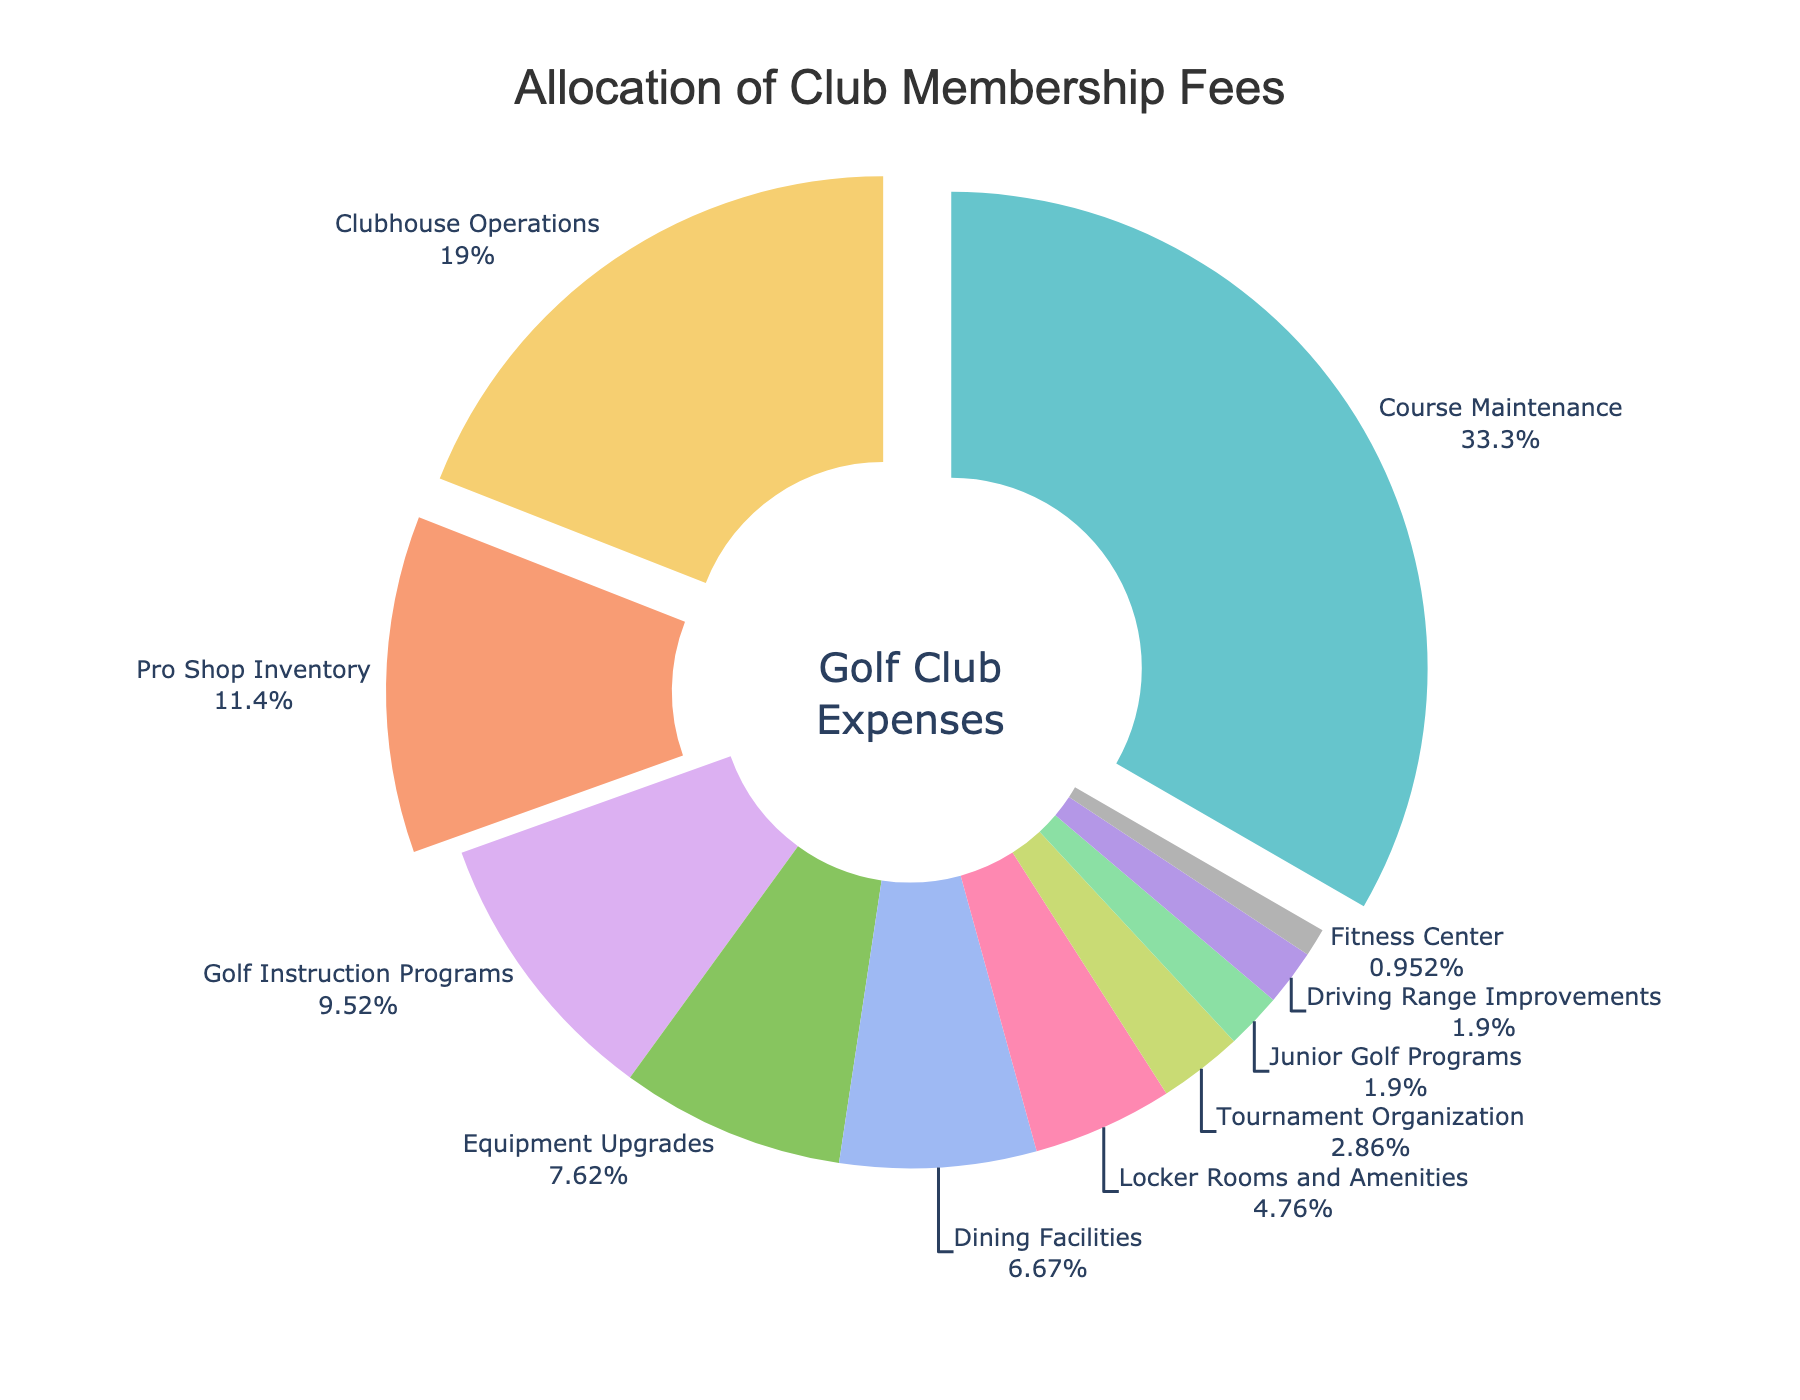Which service gets the highest allocation of membership fees? By looking at the pie chart, you can see which section occupies the largest portion. The "Course Maintenance" section is the largest.
Answer: Course Maintenance How much more percentage is allocated to Clubhouse Operations compared to Pro Shop Inventory? Clubhouse Operations has a percentage of 20, while Pro Shop Inventory has 12. The difference is 20 - 12.
Answer: 8 Which three services have the smallest allocation percentages together? From the chart, the three smallest sections are Fitness Center (1%), Junior Golf Programs (2%), and Driving Range Improvements (2%). Their combined percentage is 1 + 2 + 2.
Answer: 5% What percentage of the membership fees is allocated to services related to equipment (Pro Shop Inventory + Equipment Upgrades)? Pro Shop Inventory is 12% and Equipment Upgrades is 8%. Adding these two gives 12 + 8.
Answer: 20% Is the allocation for Dining Facilities higher or lower than that for Golf Instruction Programs? Comparing the two sections, Dining Facilities has 7% and Golf Instruction Programs has 10%. 7 is less than 10.
Answer: Lower What is the combined percentage for Tournament Organization and Junior Golf Programs? Tournament Organization is 3% and Junior Golf Programs is 2%. Adding these two together will be 3 + 2.
Answer: 5% Which section pulled outwards more in the pie chart, indicating higher prominence? The sections that are pulled outwards in the pie chart are those with the highest percentage allocations. Course Maintenance, Clubhouse Operations, and Pro Shop Inventory are pulled out.
Answer: Course Maintenance, Clubhouse Operations, and Pro Shop Inventory What is the percentage difference between the highest and lowest allocated services? The highest allocated service is Course Maintenance (35%), and the lowest is Fitness Center (1%). The difference is 35 - 1.
Answer: 34 How do the combined percentages of Pro Shop Inventory and Golf Instruction Programs compare to Clubhouse Operations? Pro Shop Inventory is 12% and Golf Instruction Programs is 10%, summing them gives 12 + 10 = 22%. Clubhouse Operations is 20%. 22 is more than 20.
Answer: Higher What proportion of the pie chart's total percentage do the top three services collectively represent? The top three services are Course Maintenance (35%), Clubhouse Operations (20%), and Pro Shop Inventory (12%). Adding these together gives 35 + 20 + 12.
Answer: 67% 